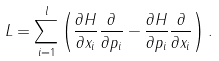Convert formula to latex. <formula><loc_0><loc_0><loc_500><loc_500>L = \sum _ { i = 1 } ^ { l } \left ( \frac { \partial H } { \partial x _ { i } } \frac { \partial } { \partial p _ { i } } - \frac { \partial H } { \partial p _ { i } } \frac { \partial } { \partial x _ { i } } \right ) .</formula> 